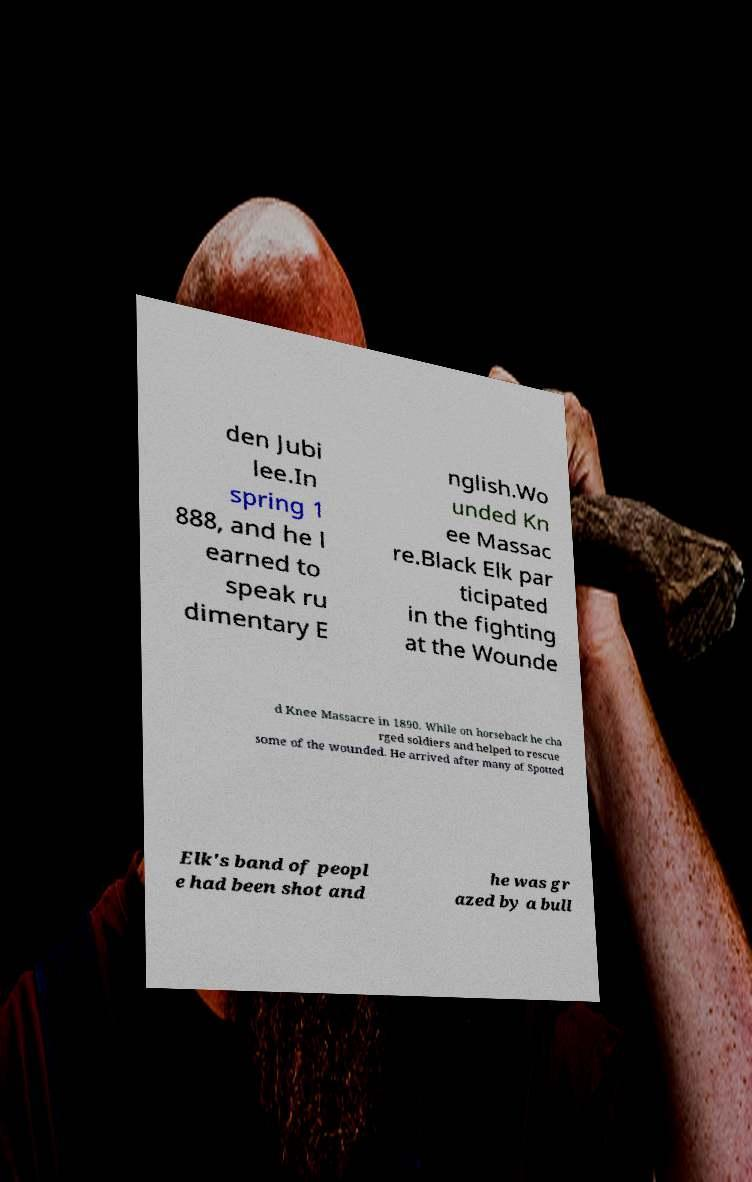Could you extract and type out the text from this image? den Jubi lee.In spring 1 888, and he l earned to speak ru dimentary E nglish.Wo unded Kn ee Massac re.Black Elk par ticipated in the fighting at the Wounde d Knee Massacre in 1890. While on horseback he cha rged soldiers and helped to rescue some of the wounded. He arrived after many of Spotted Elk's band of peopl e had been shot and he was gr azed by a bull 